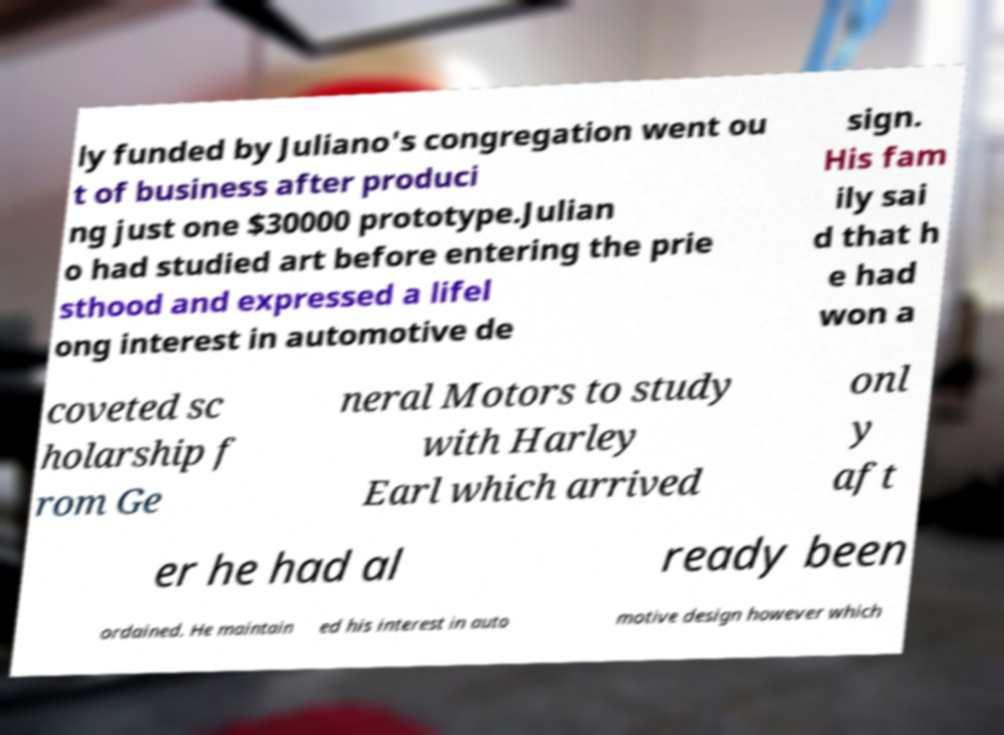There's text embedded in this image that I need extracted. Can you transcribe it verbatim? ly funded by Juliano's congregation went ou t of business after produci ng just one $30000 prototype.Julian o had studied art before entering the prie sthood and expressed a lifel ong interest in automotive de sign. His fam ily sai d that h e had won a coveted sc holarship f rom Ge neral Motors to study with Harley Earl which arrived onl y aft er he had al ready been ordained. He maintain ed his interest in auto motive design however which 